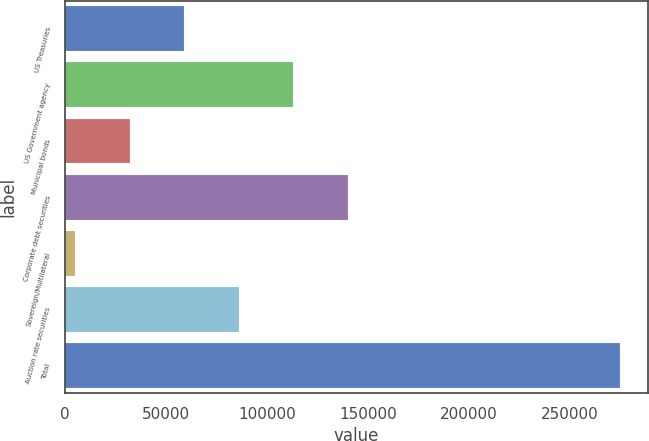<chart> <loc_0><loc_0><loc_500><loc_500><bar_chart><fcel>US Treasuries<fcel>US Government agency<fcel>Municipal bonds<fcel>Corporate debt securities<fcel>Sovereign/Multilateral<fcel>Auction rate securities<fcel>Total<nl><fcel>59145.8<fcel>113104<fcel>32166.9<fcel>140082<fcel>5188<fcel>86124.7<fcel>274977<nl></chart> 